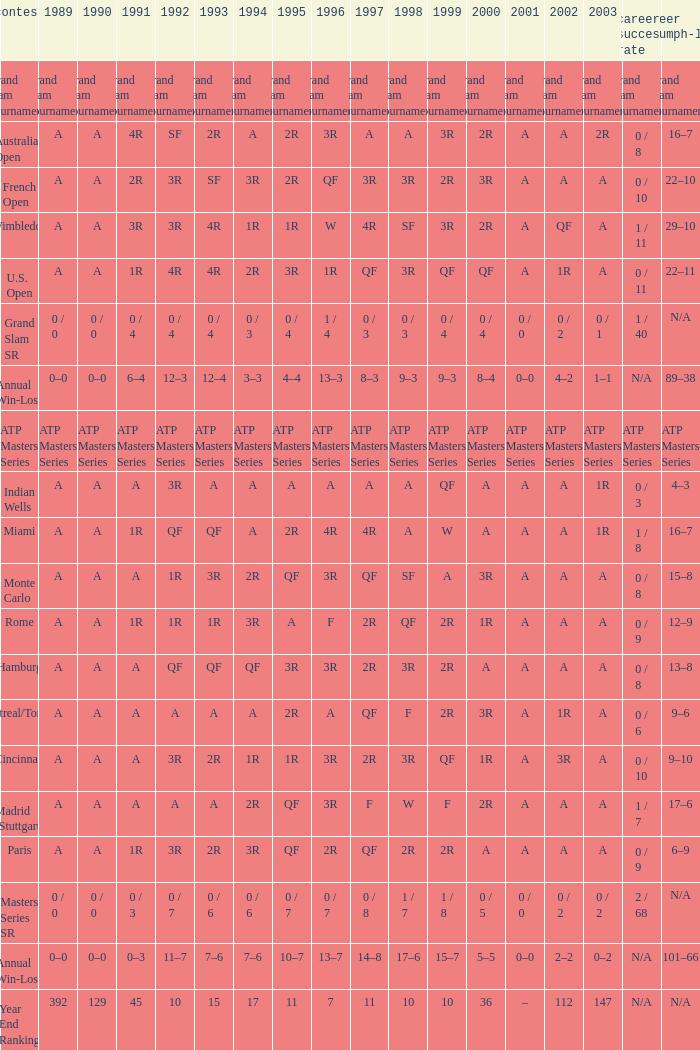What was the career SR with a value of A in 1980 and F in 1997? 1 / 7. 